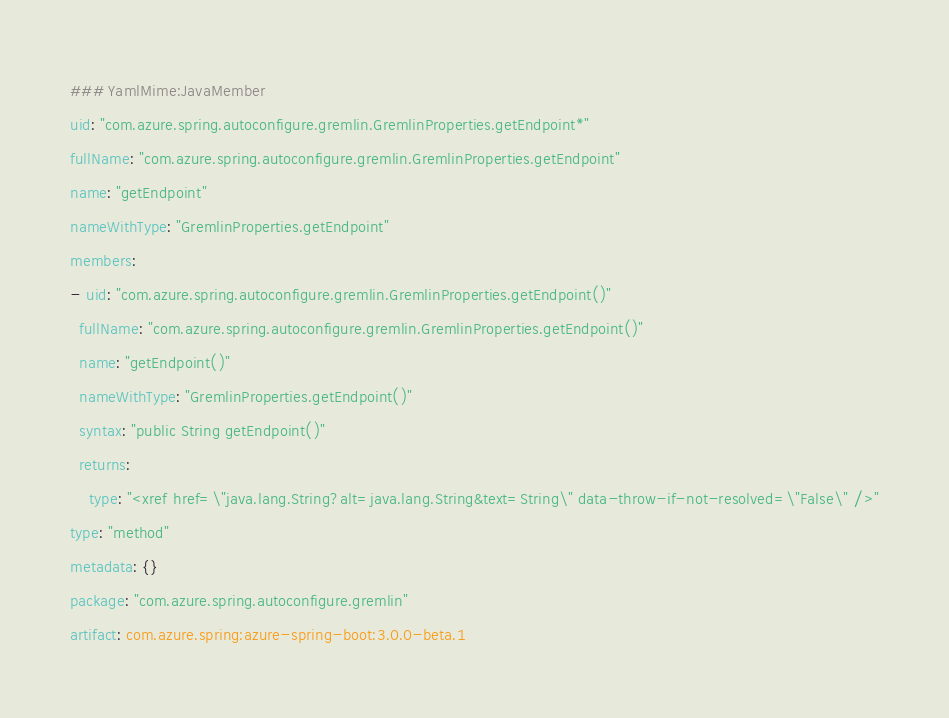Convert code to text. <code><loc_0><loc_0><loc_500><loc_500><_YAML_>### YamlMime:JavaMember
uid: "com.azure.spring.autoconfigure.gremlin.GremlinProperties.getEndpoint*"
fullName: "com.azure.spring.autoconfigure.gremlin.GremlinProperties.getEndpoint"
name: "getEndpoint"
nameWithType: "GremlinProperties.getEndpoint"
members:
- uid: "com.azure.spring.autoconfigure.gremlin.GremlinProperties.getEndpoint()"
  fullName: "com.azure.spring.autoconfigure.gremlin.GremlinProperties.getEndpoint()"
  name: "getEndpoint()"
  nameWithType: "GremlinProperties.getEndpoint()"
  syntax: "public String getEndpoint()"
  returns:
    type: "<xref href=\"java.lang.String?alt=java.lang.String&text=String\" data-throw-if-not-resolved=\"False\" />"
type: "method"
metadata: {}
package: "com.azure.spring.autoconfigure.gremlin"
artifact: com.azure.spring:azure-spring-boot:3.0.0-beta.1
</code> 